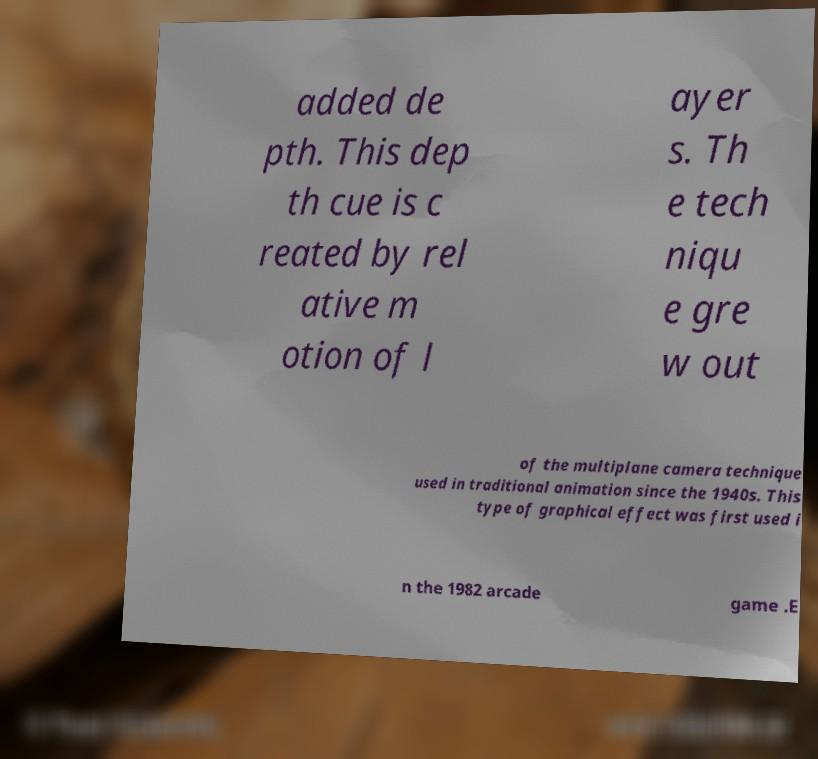For documentation purposes, I need the text within this image transcribed. Could you provide that? added de pth. This dep th cue is c reated by rel ative m otion of l ayer s. Th e tech niqu e gre w out of the multiplane camera technique used in traditional animation since the 1940s. This type of graphical effect was first used i n the 1982 arcade game .E 